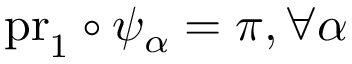<formula> <loc_0><loc_0><loc_500><loc_500>p r _ { 1 } \circ \psi _ { \alpha } = \pi , \forall \alpha</formula> 